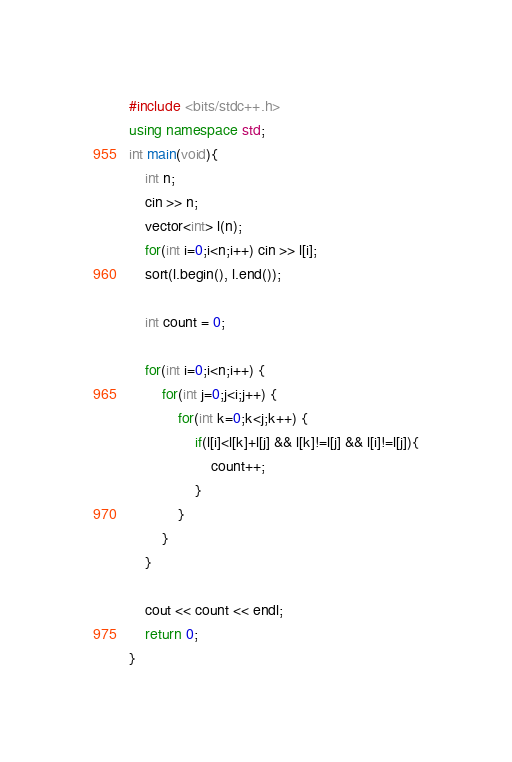Convert code to text. <code><loc_0><loc_0><loc_500><loc_500><_C++_>#include <bits/stdc++.h>
using namespace std;
int main(void){
    int n;
    cin >> n;
    vector<int> l(n);
    for(int i=0;i<n;i++) cin >> l[i];
    sort(l.begin(), l.end());
 
    int count = 0;
 
    for(int i=0;i<n;i++) {
        for(int j=0;j<i;j++) {
            for(int k=0;k<j;k++) {
                if(l[i]<l[k]+l[j] && l[k]!=l[j] && l[i]!=l[j]){
                    count++;
                }
            }
        }
    }
 
    cout << count << endl;
    return 0;
}
</code> 